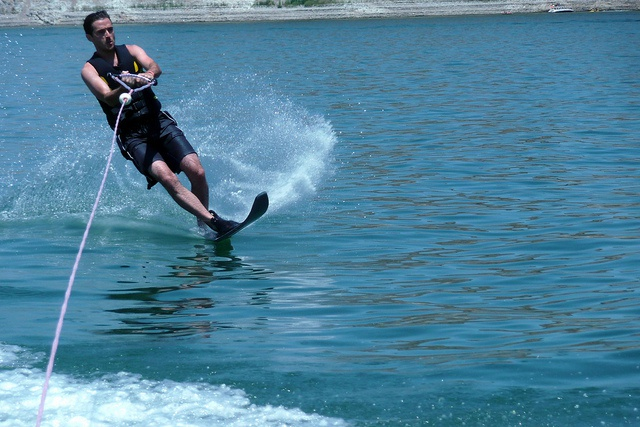Describe the objects in this image and their specific colors. I can see people in darkgray, black, gray, and navy tones in this image. 